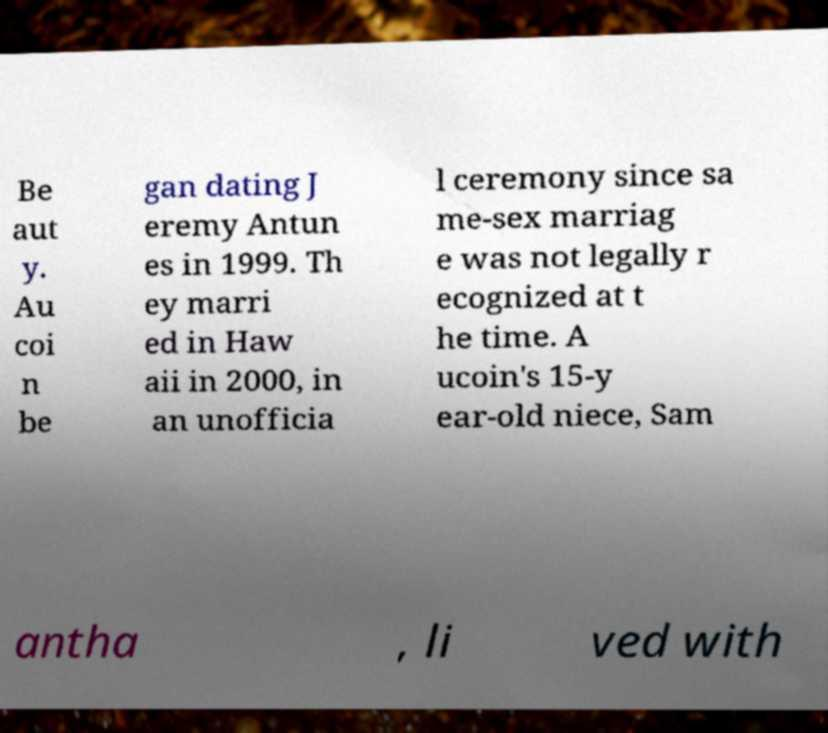Can you read and provide the text displayed in the image?This photo seems to have some interesting text. Can you extract and type it out for me? Be aut y. Au coi n be gan dating J eremy Antun es in 1999. Th ey marri ed in Haw aii in 2000, in an unofficia l ceremony since sa me-sex marriag e was not legally r ecognized at t he time. A ucoin's 15-y ear-old niece, Sam antha , li ved with 